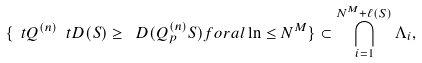<formula> <loc_0><loc_0><loc_500><loc_500>\{ \ t Q ^ { ( n ) } \ t D ( S ) \geq \ D ( Q _ { p } ^ { ( n ) } S ) f o r a l \ln \leq N ^ { M } \} \subset \bigcap _ { i = 1 } ^ { N ^ { M } + \ell ( S ) } \Lambda _ { i } ,</formula> 